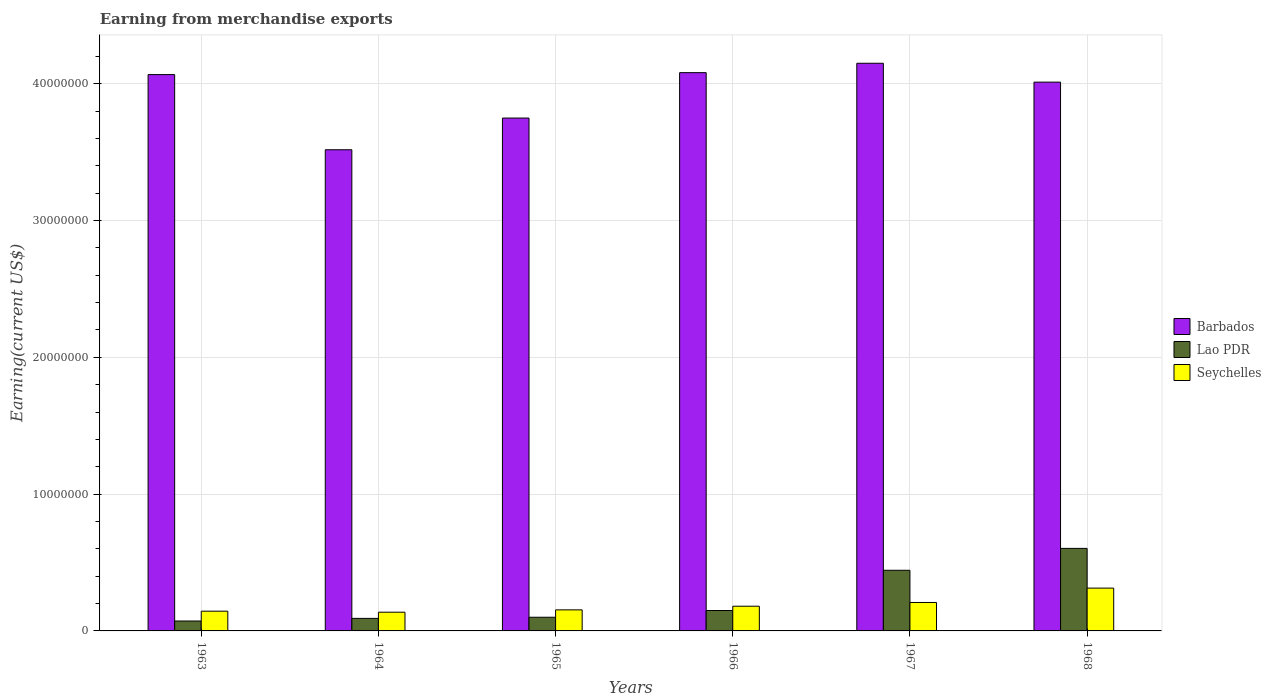How many different coloured bars are there?
Your answer should be very brief. 3. How many groups of bars are there?
Your response must be concise. 6. Are the number of bars per tick equal to the number of legend labels?
Your answer should be compact. Yes. Are the number of bars on each tick of the X-axis equal?
Provide a succinct answer. Yes. How many bars are there on the 6th tick from the left?
Ensure brevity in your answer.  3. What is the label of the 4th group of bars from the left?
Your answer should be very brief. 1966. In how many cases, is the number of bars for a given year not equal to the number of legend labels?
Keep it short and to the point. 0. What is the amount earned from merchandise exports in Seychelles in 1965?
Offer a terse response. 1.54e+06. Across all years, what is the maximum amount earned from merchandise exports in Barbados?
Your response must be concise. 4.15e+07. Across all years, what is the minimum amount earned from merchandise exports in Seychelles?
Provide a succinct answer. 1.37e+06. In which year was the amount earned from merchandise exports in Barbados maximum?
Keep it short and to the point. 1967. In which year was the amount earned from merchandise exports in Seychelles minimum?
Ensure brevity in your answer.  1964. What is the total amount earned from merchandise exports in Barbados in the graph?
Ensure brevity in your answer.  2.36e+08. What is the difference between the amount earned from merchandise exports in Barbados in 1963 and that in 1964?
Your answer should be very brief. 5.49e+06. What is the difference between the amount earned from merchandise exports in Barbados in 1965 and the amount earned from merchandise exports in Seychelles in 1968?
Your answer should be compact. 3.44e+07. What is the average amount earned from merchandise exports in Seychelles per year?
Offer a terse response. 1.89e+06. In the year 1965, what is the difference between the amount earned from merchandise exports in Seychelles and amount earned from merchandise exports in Barbados?
Ensure brevity in your answer.  -3.60e+07. What is the ratio of the amount earned from merchandise exports in Barbados in 1964 to that in 1968?
Provide a short and direct response. 0.88. Is the amount earned from merchandise exports in Barbados in 1966 less than that in 1968?
Offer a terse response. No. Is the difference between the amount earned from merchandise exports in Seychelles in 1963 and 1967 greater than the difference between the amount earned from merchandise exports in Barbados in 1963 and 1967?
Your answer should be compact. Yes. What is the difference between the highest and the second highest amount earned from merchandise exports in Lao PDR?
Provide a succinct answer. 1.60e+06. What is the difference between the highest and the lowest amount earned from merchandise exports in Barbados?
Give a very brief answer. 6.32e+06. In how many years, is the amount earned from merchandise exports in Seychelles greater than the average amount earned from merchandise exports in Seychelles taken over all years?
Offer a terse response. 2. Is the sum of the amount earned from merchandise exports in Barbados in 1963 and 1964 greater than the maximum amount earned from merchandise exports in Lao PDR across all years?
Your answer should be very brief. Yes. What does the 3rd bar from the left in 1967 represents?
Make the answer very short. Seychelles. What does the 1st bar from the right in 1967 represents?
Keep it short and to the point. Seychelles. Is it the case that in every year, the sum of the amount earned from merchandise exports in Seychelles and amount earned from merchandise exports in Lao PDR is greater than the amount earned from merchandise exports in Barbados?
Provide a succinct answer. No. Are all the bars in the graph horizontal?
Give a very brief answer. No. How many years are there in the graph?
Offer a terse response. 6. Are the values on the major ticks of Y-axis written in scientific E-notation?
Keep it short and to the point. No. Does the graph contain any zero values?
Provide a succinct answer. No. Where does the legend appear in the graph?
Offer a very short reply. Center right. How are the legend labels stacked?
Ensure brevity in your answer.  Vertical. What is the title of the graph?
Give a very brief answer. Earning from merchandise exports. What is the label or title of the Y-axis?
Offer a terse response. Earning(current US$). What is the Earning(current US$) of Barbados in 1963?
Your answer should be compact. 4.07e+07. What is the Earning(current US$) in Lao PDR in 1963?
Give a very brief answer. 7.25e+05. What is the Earning(current US$) in Seychelles in 1963?
Give a very brief answer. 1.44e+06. What is the Earning(current US$) of Barbados in 1964?
Provide a succinct answer. 3.52e+07. What is the Earning(current US$) of Lao PDR in 1964?
Offer a very short reply. 9.17e+05. What is the Earning(current US$) in Seychelles in 1964?
Ensure brevity in your answer.  1.37e+06. What is the Earning(current US$) in Barbados in 1965?
Your answer should be very brief. 3.75e+07. What is the Earning(current US$) in Lao PDR in 1965?
Your answer should be very brief. 1.00e+06. What is the Earning(current US$) of Seychelles in 1965?
Provide a short and direct response. 1.54e+06. What is the Earning(current US$) of Barbados in 1966?
Give a very brief answer. 4.08e+07. What is the Earning(current US$) of Lao PDR in 1966?
Offer a terse response. 1.49e+06. What is the Earning(current US$) of Seychelles in 1966?
Your answer should be very brief. 1.81e+06. What is the Earning(current US$) in Barbados in 1967?
Your answer should be very brief. 4.15e+07. What is the Earning(current US$) in Lao PDR in 1967?
Offer a terse response. 4.43e+06. What is the Earning(current US$) of Seychelles in 1967?
Give a very brief answer. 2.08e+06. What is the Earning(current US$) of Barbados in 1968?
Your answer should be very brief. 4.01e+07. What is the Earning(current US$) in Lao PDR in 1968?
Your response must be concise. 6.03e+06. What is the Earning(current US$) in Seychelles in 1968?
Make the answer very short. 3.13e+06. Across all years, what is the maximum Earning(current US$) of Barbados?
Ensure brevity in your answer.  4.15e+07. Across all years, what is the maximum Earning(current US$) in Lao PDR?
Offer a terse response. 6.03e+06. Across all years, what is the maximum Earning(current US$) in Seychelles?
Offer a terse response. 3.13e+06. Across all years, what is the minimum Earning(current US$) of Barbados?
Your answer should be very brief. 3.52e+07. Across all years, what is the minimum Earning(current US$) in Lao PDR?
Ensure brevity in your answer.  7.25e+05. Across all years, what is the minimum Earning(current US$) in Seychelles?
Ensure brevity in your answer.  1.37e+06. What is the total Earning(current US$) in Barbados in the graph?
Provide a short and direct response. 2.36e+08. What is the total Earning(current US$) of Lao PDR in the graph?
Offer a very short reply. 1.46e+07. What is the total Earning(current US$) of Seychelles in the graph?
Your answer should be very brief. 1.14e+07. What is the difference between the Earning(current US$) in Barbados in 1963 and that in 1964?
Ensure brevity in your answer.  5.49e+06. What is the difference between the Earning(current US$) in Lao PDR in 1963 and that in 1964?
Your response must be concise. -1.92e+05. What is the difference between the Earning(current US$) in Seychelles in 1963 and that in 1964?
Make the answer very short. 7.35e+04. What is the difference between the Earning(current US$) in Barbados in 1963 and that in 1965?
Your answer should be very brief. 3.18e+06. What is the difference between the Earning(current US$) in Lao PDR in 1963 and that in 1965?
Give a very brief answer. -2.75e+05. What is the difference between the Earning(current US$) in Seychelles in 1963 and that in 1965?
Offer a terse response. -9.66e+04. What is the difference between the Earning(current US$) of Barbados in 1963 and that in 1966?
Ensure brevity in your answer.  -1.42e+05. What is the difference between the Earning(current US$) of Lao PDR in 1963 and that in 1966?
Ensure brevity in your answer.  -7.67e+05. What is the difference between the Earning(current US$) in Seychelles in 1963 and that in 1966?
Make the answer very short. -3.63e+05. What is the difference between the Earning(current US$) of Barbados in 1963 and that in 1967?
Provide a short and direct response. -8.29e+05. What is the difference between the Earning(current US$) in Lao PDR in 1963 and that in 1967?
Your answer should be very brief. -3.71e+06. What is the difference between the Earning(current US$) in Seychelles in 1963 and that in 1967?
Your response must be concise. -6.37e+05. What is the difference between the Earning(current US$) of Barbados in 1963 and that in 1968?
Provide a short and direct response. 5.52e+05. What is the difference between the Earning(current US$) in Lao PDR in 1963 and that in 1968?
Your answer should be compact. -5.31e+06. What is the difference between the Earning(current US$) in Seychelles in 1963 and that in 1968?
Your answer should be very brief. -1.69e+06. What is the difference between the Earning(current US$) of Barbados in 1964 and that in 1965?
Offer a very short reply. -2.32e+06. What is the difference between the Earning(current US$) of Lao PDR in 1964 and that in 1965?
Provide a succinct answer. -8.30e+04. What is the difference between the Earning(current US$) of Seychelles in 1964 and that in 1965?
Give a very brief answer. -1.70e+05. What is the difference between the Earning(current US$) of Barbados in 1964 and that in 1966?
Your answer should be very brief. -5.64e+06. What is the difference between the Earning(current US$) of Lao PDR in 1964 and that in 1966?
Make the answer very short. -5.75e+05. What is the difference between the Earning(current US$) of Seychelles in 1964 and that in 1966?
Give a very brief answer. -4.37e+05. What is the difference between the Earning(current US$) of Barbados in 1964 and that in 1967?
Ensure brevity in your answer.  -6.32e+06. What is the difference between the Earning(current US$) in Lao PDR in 1964 and that in 1967?
Your response must be concise. -3.52e+06. What is the difference between the Earning(current US$) in Seychelles in 1964 and that in 1967?
Provide a short and direct response. -7.10e+05. What is the difference between the Earning(current US$) of Barbados in 1964 and that in 1968?
Give a very brief answer. -4.94e+06. What is the difference between the Earning(current US$) in Lao PDR in 1964 and that in 1968?
Provide a short and direct response. -5.12e+06. What is the difference between the Earning(current US$) of Seychelles in 1964 and that in 1968?
Ensure brevity in your answer.  -1.76e+06. What is the difference between the Earning(current US$) of Barbados in 1965 and that in 1966?
Ensure brevity in your answer.  -3.32e+06. What is the difference between the Earning(current US$) of Lao PDR in 1965 and that in 1966?
Offer a very short reply. -4.92e+05. What is the difference between the Earning(current US$) of Seychelles in 1965 and that in 1966?
Give a very brief answer. -2.67e+05. What is the difference between the Earning(current US$) in Barbados in 1965 and that in 1967?
Make the answer very short. -4.01e+06. What is the difference between the Earning(current US$) of Lao PDR in 1965 and that in 1967?
Give a very brief answer. -3.43e+06. What is the difference between the Earning(current US$) in Seychelles in 1965 and that in 1967?
Offer a terse response. -5.40e+05. What is the difference between the Earning(current US$) of Barbados in 1965 and that in 1968?
Ensure brevity in your answer.  -2.63e+06. What is the difference between the Earning(current US$) of Lao PDR in 1965 and that in 1968?
Keep it short and to the point. -5.03e+06. What is the difference between the Earning(current US$) in Seychelles in 1965 and that in 1968?
Ensure brevity in your answer.  -1.59e+06. What is the difference between the Earning(current US$) of Barbados in 1966 and that in 1967?
Make the answer very short. -6.86e+05. What is the difference between the Earning(current US$) in Lao PDR in 1966 and that in 1967?
Provide a short and direct response. -2.94e+06. What is the difference between the Earning(current US$) of Seychelles in 1966 and that in 1967?
Provide a short and direct response. -2.74e+05. What is the difference between the Earning(current US$) in Barbados in 1966 and that in 1968?
Offer a very short reply. 6.94e+05. What is the difference between the Earning(current US$) of Lao PDR in 1966 and that in 1968?
Keep it short and to the point. -4.54e+06. What is the difference between the Earning(current US$) in Seychelles in 1966 and that in 1968?
Ensure brevity in your answer.  -1.32e+06. What is the difference between the Earning(current US$) of Barbados in 1967 and that in 1968?
Your answer should be compact. 1.38e+06. What is the difference between the Earning(current US$) of Lao PDR in 1967 and that in 1968?
Your answer should be very brief. -1.60e+06. What is the difference between the Earning(current US$) of Seychelles in 1967 and that in 1968?
Provide a succinct answer. -1.05e+06. What is the difference between the Earning(current US$) of Barbados in 1963 and the Earning(current US$) of Lao PDR in 1964?
Provide a short and direct response. 3.98e+07. What is the difference between the Earning(current US$) of Barbados in 1963 and the Earning(current US$) of Seychelles in 1964?
Offer a very short reply. 3.93e+07. What is the difference between the Earning(current US$) of Lao PDR in 1963 and the Earning(current US$) of Seychelles in 1964?
Ensure brevity in your answer.  -6.44e+05. What is the difference between the Earning(current US$) in Barbados in 1963 and the Earning(current US$) in Lao PDR in 1965?
Your response must be concise. 3.97e+07. What is the difference between the Earning(current US$) in Barbados in 1963 and the Earning(current US$) in Seychelles in 1965?
Offer a very short reply. 3.91e+07. What is the difference between the Earning(current US$) in Lao PDR in 1963 and the Earning(current US$) in Seychelles in 1965?
Ensure brevity in your answer.  -8.14e+05. What is the difference between the Earning(current US$) of Barbados in 1963 and the Earning(current US$) of Lao PDR in 1966?
Offer a very short reply. 3.92e+07. What is the difference between the Earning(current US$) in Barbados in 1963 and the Earning(current US$) in Seychelles in 1966?
Offer a terse response. 3.89e+07. What is the difference between the Earning(current US$) of Lao PDR in 1963 and the Earning(current US$) of Seychelles in 1966?
Ensure brevity in your answer.  -1.08e+06. What is the difference between the Earning(current US$) in Barbados in 1963 and the Earning(current US$) in Lao PDR in 1967?
Give a very brief answer. 3.62e+07. What is the difference between the Earning(current US$) in Barbados in 1963 and the Earning(current US$) in Seychelles in 1967?
Offer a terse response. 3.86e+07. What is the difference between the Earning(current US$) of Lao PDR in 1963 and the Earning(current US$) of Seychelles in 1967?
Your answer should be very brief. -1.35e+06. What is the difference between the Earning(current US$) in Barbados in 1963 and the Earning(current US$) in Lao PDR in 1968?
Keep it short and to the point. 3.46e+07. What is the difference between the Earning(current US$) of Barbados in 1963 and the Earning(current US$) of Seychelles in 1968?
Keep it short and to the point. 3.75e+07. What is the difference between the Earning(current US$) in Lao PDR in 1963 and the Earning(current US$) in Seychelles in 1968?
Offer a very short reply. -2.41e+06. What is the difference between the Earning(current US$) in Barbados in 1964 and the Earning(current US$) in Lao PDR in 1965?
Ensure brevity in your answer.  3.42e+07. What is the difference between the Earning(current US$) of Barbados in 1964 and the Earning(current US$) of Seychelles in 1965?
Provide a succinct answer. 3.36e+07. What is the difference between the Earning(current US$) in Lao PDR in 1964 and the Earning(current US$) in Seychelles in 1965?
Your answer should be very brief. -6.22e+05. What is the difference between the Earning(current US$) of Barbados in 1964 and the Earning(current US$) of Lao PDR in 1966?
Keep it short and to the point. 3.37e+07. What is the difference between the Earning(current US$) in Barbados in 1964 and the Earning(current US$) in Seychelles in 1966?
Offer a very short reply. 3.34e+07. What is the difference between the Earning(current US$) in Lao PDR in 1964 and the Earning(current US$) in Seychelles in 1966?
Your response must be concise. -8.89e+05. What is the difference between the Earning(current US$) in Barbados in 1964 and the Earning(current US$) in Lao PDR in 1967?
Your answer should be compact. 3.07e+07. What is the difference between the Earning(current US$) of Barbados in 1964 and the Earning(current US$) of Seychelles in 1967?
Your answer should be very brief. 3.31e+07. What is the difference between the Earning(current US$) in Lao PDR in 1964 and the Earning(current US$) in Seychelles in 1967?
Your answer should be very brief. -1.16e+06. What is the difference between the Earning(current US$) in Barbados in 1964 and the Earning(current US$) in Lao PDR in 1968?
Your response must be concise. 2.91e+07. What is the difference between the Earning(current US$) in Barbados in 1964 and the Earning(current US$) in Seychelles in 1968?
Give a very brief answer. 3.20e+07. What is the difference between the Earning(current US$) of Lao PDR in 1964 and the Earning(current US$) of Seychelles in 1968?
Your answer should be very brief. -2.21e+06. What is the difference between the Earning(current US$) of Barbados in 1965 and the Earning(current US$) of Lao PDR in 1966?
Provide a short and direct response. 3.60e+07. What is the difference between the Earning(current US$) of Barbados in 1965 and the Earning(current US$) of Seychelles in 1966?
Keep it short and to the point. 3.57e+07. What is the difference between the Earning(current US$) of Lao PDR in 1965 and the Earning(current US$) of Seychelles in 1966?
Keep it short and to the point. -8.06e+05. What is the difference between the Earning(current US$) in Barbados in 1965 and the Earning(current US$) in Lao PDR in 1967?
Make the answer very short. 3.31e+07. What is the difference between the Earning(current US$) in Barbados in 1965 and the Earning(current US$) in Seychelles in 1967?
Ensure brevity in your answer.  3.54e+07. What is the difference between the Earning(current US$) of Lao PDR in 1965 and the Earning(current US$) of Seychelles in 1967?
Keep it short and to the point. -1.08e+06. What is the difference between the Earning(current US$) in Barbados in 1965 and the Earning(current US$) in Lao PDR in 1968?
Your answer should be very brief. 3.15e+07. What is the difference between the Earning(current US$) of Barbados in 1965 and the Earning(current US$) of Seychelles in 1968?
Provide a short and direct response. 3.44e+07. What is the difference between the Earning(current US$) of Lao PDR in 1965 and the Earning(current US$) of Seychelles in 1968?
Give a very brief answer. -2.13e+06. What is the difference between the Earning(current US$) of Barbados in 1966 and the Earning(current US$) of Lao PDR in 1967?
Provide a short and direct response. 3.64e+07. What is the difference between the Earning(current US$) in Barbados in 1966 and the Earning(current US$) in Seychelles in 1967?
Your response must be concise. 3.87e+07. What is the difference between the Earning(current US$) of Lao PDR in 1966 and the Earning(current US$) of Seychelles in 1967?
Offer a terse response. -5.88e+05. What is the difference between the Earning(current US$) in Barbados in 1966 and the Earning(current US$) in Lao PDR in 1968?
Keep it short and to the point. 3.48e+07. What is the difference between the Earning(current US$) of Barbados in 1966 and the Earning(current US$) of Seychelles in 1968?
Offer a terse response. 3.77e+07. What is the difference between the Earning(current US$) in Lao PDR in 1966 and the Earning(current US$) in Seychelles in 1968?
Your answer should be compact. -1.64e+06. What is the difference between the Earning(current US$) in Barbados in 1967 and the Earning(current US$) in Lao PDR in 1968?
Your response must be concise. 3.55e+07. What is the difference between the Earning(current US$) in Barbados in 1967 and the Earning(current US$) in Seychelles in 1968?
Your answer should be very brief. 3.84e+07. What is the difference between the Earning(current US$) in Lao PDR in 1967 and the Earning(current US$) in Seychelles in 1968?
Offer a very short reply. 1.30e+06. What is the average Earning(current US$) in Barbados per year?
Offer a terse response. 3.93e+07. What is the average Earning(current US$) of Lao PDR per year?
Offer a very short reply. 2.43e+06. What is the average Earning(current US$) of Seychelles per year?
Make the answer very short. 1.89e+06. In the year 1963, what is the difference between the Earning(current US$) in Barbados and Earning(current US$) in Lao PDR?
Keep it short and to the point. 3.99e+07. In the year 1963, what is the difference between the Earning(current US$) in Barbados and Earning(current US$) in Seychelles?
Give a very brief answer. 3.92e+07. In the year 1963, what is the difference between the Earning(current US$) of Lao PDR and Earning(current US$) of Seychelles?
Ensure brevity in your answer.  -7.18e+05. In the year 1964, what is the difference between the Earning(current US$) in Barbados and Earning(current US$) in Lao PDR?
Your response must be concise. 3.43e+07. In the year 1964, what is the difference between the Earning(current US$) of Barbados and Earning(current US$) of Seychelles?
Give a very brief answer. 3.38e+07. In the year 1964, what is the difference between the Earning(current US$) of Lao PDR and Earning(current US$) of Seychelles?
Your answer should be very brief. -4.52e+05. In the year 1965, what is the difference between the Earning(current US$) of Barbados and Earning(current US$) of Lao PDR?
Your answer should be compact. 3.65e+07. In the year 1965, what is the difference between the Earning(current US$) of Barbados and Earning(current US$) of Seychelles?
Your response must be concise. 3.60e+07. In the year 1965, what is the difference between the Earning(current US$) in Lao PDR and Earning(current US$) in Seychelles?
Keep it short and to the point. -5.39e+05. In the year 1966, what is the difference between the Earning(current US$) in Barbados and Earning(current US$) in Lao PDR?
Offer a very short reply. 3.93e+07. In the year 1966, what is the difference between the Earning(current US$) in Barbados and Earning(current US$) in Seychelles?
Your response must be concise. 3.90e+07. In the year 1966, what is the difference between the Earning(current US$) of Lao PDR and Earning(current US$) of Seychelles?
Provide a succinct answer. -3.14e+05. In the year 1967, what is the difference between the Earning(current US$) of Barbados and Earning(current US$) of Lao PDR?
Offer a terse response. 3.71e+07. In the year 1967, what is the difference between the Earning(current US$) of Barbados and Earning(current US$) of Seychelles?
Your answer should be compact. 3.94e+07. In the year 1967, what is the difference between the Earning(current US$) of Lao PDR and Earning(current US$) of Seychelles?
Make the answer very short. 2.35e+06. In the year 1968, what is the difference between the Earning(current US$) of Barbados and Earning(current US$) of Lao PDR?
Offer a terse response. 3.41e+07. In the year 1968, what is the difference between the Earning(current US$) in Barbados and Earning(current US$) in Seychelles?
Provide a short and direct response. 3.70e+07. In the year 1968, what is the difference between the Earning(current US$) of Lao PDR and Earning(current US$) of Seychelles?
Provide a short and direct response. 2.90e+06. What is the ratio of the Earning(current US$) of Barbados in 1963 to that in 1964?
Give a very brief answer. 1.16. What is the ratio of the Earning(current US$) in Lao PDR in 1963 to that in 1964?
Make the answer very short. 0.79. What is the ratio of the Earning(current US$) of Seychelles in 1963 to that in 1964?
Ensure brevity in your answer.  1.05. What is the ratio of the Earning(current US$) of Barbados in 1963 to that in 1965?
Your answer should be compact. 1.08. What is the ratio of the Earning(current US$) of Lao PDR in 1963 to that in 1965?
Your answer should be compact. 0.72. What is the ratio of the Earning(current US$) in Seychelles in 1963 to that in 1965?
Offer a terse response. 0.94. What is the ratio of the Earning(current US$) in Lao PDR in 1963 to that in 1966?
Ensure brevity in your answer.  0.49. What is the ratio of the Earning(current US$) in Seychelles in 1963 to that in 1966?
Keep it short and to the point. 0.8. What is the ratio of the Earning(current US$) of Barbados in 1963 to that in 1967?
Keep it short and to the point. 0.98. What is the ratio of the Earning(current US$) of Lao PDR in 1963 to that in 1967?
Make the answer very short. 0.16. What is the ratio of the Earning(current US$) in Seychelles in 1963 to that in 1967?
Your response must be concise. 0.69. What is the ratio of the Earning(current US$) of Barbados in 1963 to that in 1968?
Offer a terse response. 1.01. What is the ratio of the Earning(current US$) of Lao PDR in 1963 to that in 1968?
Your answer should be compact. 0.12. What is the ratio of the Earning(current US$) of Seychelles in 1963 to that in 1968?
Provide a short and direct response. 0.46. What is the ratio of the Earning(current US$) in Barbados in 1964 to that in 1965?
Your response must be concise. 0.94. What is the ratio of the Earning(current US$) in Lao PDR in 1964 to that in 1965?
Your answer should be compact. 0.92. What is the ratio of the Earning(current US$) of Seychelles in 1964 to that in 1965?
Your answer should be compact. 0.89. What is the ratio of the Earning(current US$) in Barbados in 1964 to that in 1966?
Provide a short and direct response. 0.86. What is the ratio of the Earning(current US$) in Lao PDR in 1964 to that in 1966?
Your answer should be very brief. 0.61. What is the ratio of the Earning(current US$) in Seychelles in 1964 to that in 1966?
Make the answer very short. 0.76. What is the ratio of the Earning(current US$) in Barbados in 1964 to that in 1967?
Give a very brief answer. 0.85. What is the ratio of the Earning(current US$) of Lao PDR in 1964 to that in 1967?
Provide a short and direct response. 0.21. What is the ratio of the Earning(current US$) in Seychelles in 1964 to that in 1967?
Provide a succinct answer. 0.66. What is the ratio of the Earning(current US$) of Barbados in 1964 to that in 1968?
Your answer should be very brief. 0.88. What is the ratio of the Earning(current US$) of Lao PDR in 1964 to that in 1968?
Give a very brief answer. 0.15. What is the ratio of the Earning(current US$) of Seychelles in 1964 to that in 1968?
Give a very brief answer. 0.44. What is the ratio of the Earning(current US$) in Barbados in 1965 to that in 1966?
Make the answer very short. 0.92. What is the ratio of the Earning(current US$) in Lao PDR in 1965 to that in 1966?
Your response must be concise. 0.67. What is the ratio of the Earning(current US$) in Seychelles in 1965 to that in 1966?
Provide a short and direct response. 0.85. What is the ratio of the Earning(current US$) of Barbados in 1965 to that in 1967?
Your answer should be very brief. 0.9. What is the ratio of the Earning(current US$) of Lao PDR in 1965 to that in 1967?
Make the answer very short. 0.23. What is the ratio of the Earning(current US$) of Seychelles in 1965 to that in 1967?
Provide a succinct answer. 0.74. What is the ratio of the Earning(current US$) of Barbados in 1965 to that in 1968?
Your response must be concise. 0.93. What is the ratio of the Earning(current US$) of Lao PDR in 1965 to that in 1968?
Offer a terse response. 0.17. What is the ratio of the Earning(current US$) of Seychelles in 1965 to that in 1968?
Ensure brevity in your answer.  0.49. What is the ratio of the Earning(current US$) of Barbados in 1966 to that in 1967?
Ensure brevity in your answer.  0.98. What is the ratio of the Earning(current US$) in Lao PDR in 1966 to that in 1967?
Offer a very short reply. 0.34. What is the ratio of the Earning(current US$) in Seychelles in 1966 to that in 1967?
Give a very brief answer. 0.87. What is the ratio of the Earning(current US$) in Barbados in 1966 to that in 1968?
Ensure brevity in your answer.  1.02. What is the ratio of the Earning(current US$) in Lao PDR in 1966 to that in 1968?
Ensure brevity in your answer.  0.25. What is the ratio of the Earning(current US$) of Seychelles in 1966 to that in 1968?
Make the answer very short. 0.58. What is the ratio of the Earning(current US$) of Barbados in 1967 to that in 1968?
Offer a very short reply. 1.03. What is the ratio of the Earning(current US$) in Lao PDR in 1967 to that in 1968?
Make the answer very short. 0.73. What is the ratio of the Earning(current US$) of Seychelles in 1967 to that in 1968?
Your answer should be compact. 0.66. What is the difference between the highest and the second highest Earning(current US$) in Barbados?
Your response must be concise. 6.86e+05. What is the difference between the highest and the second highest Earning(current US$) of Lao PDR?
Ensure brevity in your answer.  1.60e+06. What is the difference between the highest and the second highest Earning(current US$) of Seychelles?
Your answer should be very brief. 1.05e+06. What is the difference between the highest and the lowest Earning(current US$) in Barbados?
Make the answer very short. 6.32e+06. What is the difference between the highest and the lowest Earning(current US$) in Lao PDR?
Keep it short and to the point. 5.31e+06. What is the difference between the highest and the lowest Earning(current US$) in Seychelles?
Ensure brevity in your answer.  1.76e+06. 